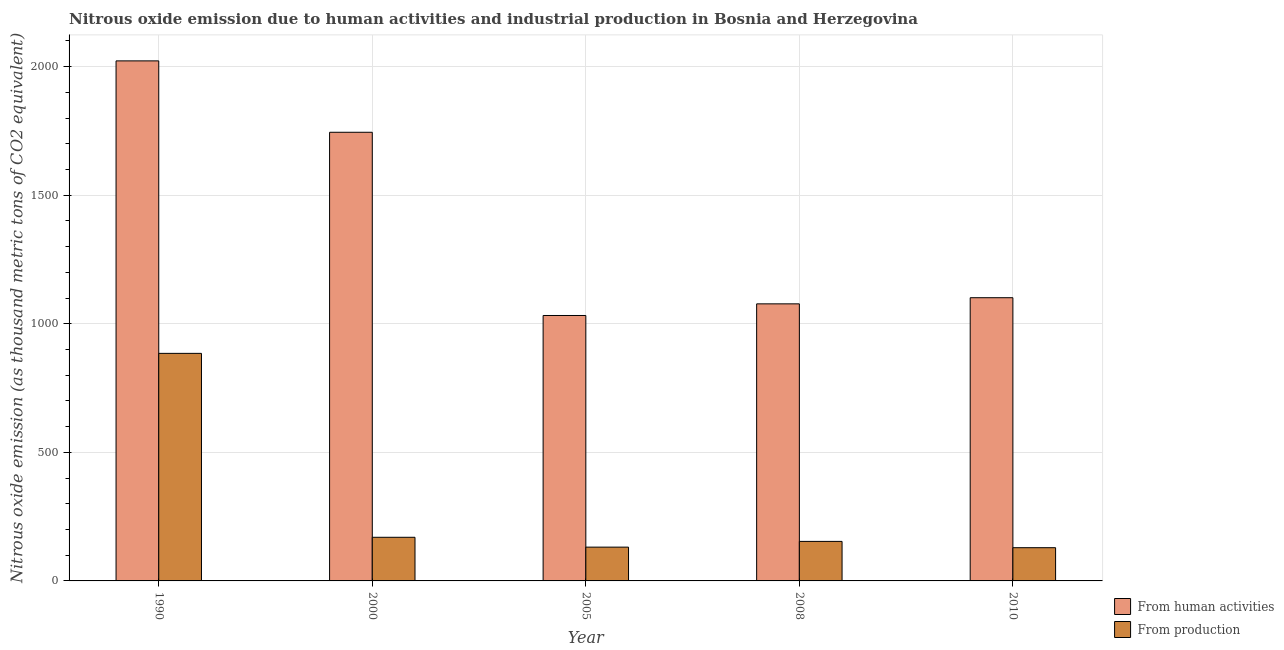How many groups of bars are there?
Ensure brevity in your answer.  5. How many bars are there on the 4th tick from the left?
Provide a succinct answer. 2. How many bars are there on the 3rd tick from the right?
Your answer should be compact. 2. In how many cases, is the number of bars for a given year not equal to the number of legend labels?
Offer a very short reply. 0. What is the amount of emissions from human activities in 2000?
Your answer should be very brief. 1744.9. Across all years, what is the maximum amount of emissions generated from industries?
Give a very brief answer. 885. Across all years, what is the minimum amount of emissions from human activities?
Offer a terse response. 1032.3. What is the total amount of emissions from human activities in the graph?
Ensure brevity in your answer.  6978.9. What is the difference between the amount of emissions from human activities in 1990 and that in 2010?
Your response must be concise. 921.1. What is the difference between the amount of emissions from human activities in 1990 and the amount of emissions generated from industries in 2010?
Keep it short and to the point. 921.1. What is the average amount of emissions generated from industries per year?
Give a very brief answer. 293.8. What is the ratio of the amount of emissions generated from industries in 2000 to that in 2008?
Offer a very short reply. 1.1. Is the amount of emissions from human activities in 2000 less than that in 2008?
Provide a succinct answer. No. Is the difference between the amount of emissions generated from industries in 2000 and 2008 greater than the difference between the amount of emissions from human activities in 2000 and 2008?
Your answer should be very brief. No. What is the difference between the highest and the second highest amount of emissions from human activities?
Keep it short and to the point. 277.7. What is the difference between the highest and the lowest amount of emissions generated from industries?
Provide a short and direct response. 755.8. In how many years, is the amount of emissions generated from industries greater than the average amount of emissions generated from industries taken over all years?
Keep it short and to the point. 1. What does the 2nd bar from the left in 2008 represents?
Make the answer very short. From production. What does the 1st bar from the right in 2010 represents?
Your answer should be compact. From production. How many bars are there?
Offer a terse response. 10. What is the difference between two consecutive major ticks on the Y-axis?
Your answer should be very brief. 500. Are the values on the major ticks of Y-axis written in scientific E-notation?
Provide a succinct answer. No. Does the graph contain grids?
Offer a very short reply. Yes. How many legend labels are there?
Give a very brief answer. 2. What is the title of the graph?
Make the answer very short. Nitrous oxide emission due to human activities and industrial production in Bosnia and Herzegovina. Does "Underweight" appear as one of the legend labels in the graph?
Provide a succinct answer. No. What is the label or title of the Y-axis?
Offer a terse response. Nitrous oxide emission (as thousand metric tons of CO2 equivalent). What is the Nitrous oxide emission (as thousand metric tons of CO2 equivalent) in From human activities in 1990?
Ensure brevity in your answer.  2022.6. What is the Nitrous oxide emission (as thousand metric tons of CO2 equivalent) of From production in 1990?
Keep it short and to the point. 885. What is the Nitrous oxide emission (as thousand metric tons of CO2 equivalent) in From human activities in 2000?
Offer a terse response. 1744.9. What is the Nitrous oxide emission (as thousand metric tons of CO2 equivalent) in From production in 2000?
Make the answer very short. 169.7. What is the Nitrous oxide emission (as thousand metric tons of CO2 equivalent) in From human activities in 2005?
Provide a succinct answer. 1032.3. What is the Nitrous oxide emission (as thousand metric tons of CO2 equivalent) in From production in 2005?
Ensure brevity in your answer.  131.4. What is the Nitrous oxide emission (as thousand metric tons of CO2 equivalent) of From human activities in 2008?
Offer a terse response. 1077.6. What is the Nitrous oxide emission (as thousand metric tons of CO2 equivalent) in From production in 2008?
Your answer should be compact. 153.7. What is the Nitrous oxide emission (as thousand metric tons of CO2 equivalent) of From human activities in 2010?
Offer a very short reply. 1101.5. What is the Nitrous oxide emission (as thousand metric tons of CO2 equivalent) of From production in 2010?
Ensure brevity in your answer.  129.2. Across all years, what is the maximum Nitrous oxide emission (as thousand metric tons of CO2 equivalent) of From human activities?
Offer a terse response. 2022.6. Across all years, what is the maximum Nitrous oxide emission (as thousand metric tons of CO2 equivalent) in From production?
Offer a terse response. 885. Across all years, what is the minimum Nitrous oxide emission (as thousand metric tons of CO2 equivalent) in From human activities?
Your response must be concise. 1032.3. Across all years, what is the minimum Nitrous oxide emission (as thousand metric tons of CO2 equivalent) in From production?
Your response must be concise. 129.2. What is the total Nitrous oxide emission (as thousand metric tons of CO2 equivalent) of From human activities in the graph?
Offer a terse response. 6978.9. What is the total Nitrous oxide emission (as thousand metric tons of CO2 equivalent) in From production in the graph?
Keep it short and to the point. 1469. What is the difference between the Nitrous oxide emission (as thousand metric tons of CO2 equivalent) in From human activities in 1990 and that in 2000?
Provide a succinct answer. 277.7. What is the difference between the Nitrous oxide emission (as thousand metric tons of CO2 equivalent) in From production in 1990 and that in 2000?
Offer a very short reply. 715.3. What is the difference between the Nitrous oxide emission (as thousand metric tons of CO2 equivalent) of From human activities in 1990 and that in 2005?
Provide a short and direct response. 990.3. What is the difference between the Nitrous oxide emission (as thousand metric tons of CO2 equivalent) of From production in 1990 and that in 2005?
Your response must be concise. 753.6. What is the difference between the Nitrous oxide emission (as thousand metric tons of CO2 equivalent) in From human activities in 1990 and that in 2008?
Your response must be concise. 945. What is the difference between the Nitrous oxide emission (as thousand metric tons of CO2 equivalent) of From production in 1990 and that in 2008?
Your answer should be compact. 731.3. What is the difference between the Nitrous oxide emission (as thousand metric tons of CO2 equivalent) in From human activities in 1990 and that in 2010?
Give a very brief answer. 921.1. What is the difference between the Nitrous oxide emission (as thousand metric tons of CO2 equivalent) in From production in 1990 and that in 2010?
Your answer should be very brief. 755.8. What is the difference between the Nitrous oxide emission (as thousand metric tons of CO2 equivalent) in From human activities in 2000 and that in 2005?
Your answer should be very brief. 712.6. What is the difference between the Nitrous oxide emission (as thousand metric tons of CO2 equivalent) in From production in 2000 and that in 2005?
Your answer should be very brief. 38.3. What is the difference between the Nitrous oxide emission (as thousand metric tons of CO2 equivalent) in From human activities in 2000 and that in 2008?
Provide a succinct answer. 667.3. What is the difference between the Nitrous oxide emission (as thousand metric tons of CO2 equivalent) in From human activities in 2000 and that in 2010?
Give a very brief answer. 643.4. What is the difference between the Nitrous oxide emission (as thousand metric tons of CO2 equivalent) of From production in 2000 and that in 2010?
Offer a very short reply. 40.5. What is the difference between the Nitrous oxide emission (as thousand metric tons of CO2 equivalent) of From human activities in 2005 and that in 2008?
Offer a very short reply. -45.3. What is the difference between the Nitrous oxide emission (as thousand metric tons of CO2 equivalent) of From production in 2005 and that in 2008?
Ensure brevity in your answer.  -22.3. What is the difference between the Nitrous oxide emission (as thousand metric tons of CO2 equivalent) of From human activities in 2005 and that in 2010?
Your answer should be very brief. -69.2. What is the difference between the Nitrous oxide emission (as thousand metric tons of CO2 equivalent) in From production in 2005 and that in 2010?
Offer a terse response. 2.2. What is the difference between the Nitrous oxide emission (as thousand metric tons of CO2 equivalent) of From human activities in 2008 and that in 2010?
Make the answer very short. -23.9. What is the difference between the Nitrous oxide emission (as thousand metric tons of CO2 equivalent) in From human activities in 1990 and the Nitrous oxide emission (as thousand metric tons of CO2 equivalent) in From production in 2000?
Ensure brevity in your answer.  1852.9. What is the difference between the Nitrous oxide emission (as thousand metric tons of CO2 equivalent) of From human activities in 1990 and the Nitrous oxide emission (as thousand metric tons of CO2 equivalent) of From production in 2005?
Your answer should be very brief. 1891.2. What is the difference between the Nitrous oxide emission (as thousand metric tons of CO2 equivalent) of From human activities in 1990 and the Nitrous oxide emission (as thousand metric tons of CO2 equivalent) of From production in 2008?
Provide a succinct answer. 1868.9. What is the difference between the Nitrous oxide emission (as thousand metric tons of CO2 equivalent) in From human activities in 1990 and the Nitrous oxide emission (as thousand metric tons of CO2 equivalent) in From production in 2010?
Give a very brief answer. 1893.4. What is the difference between the Nitrous oxide emission (as thousand metric tons of CO2 equivalent) of From human activities in 2000 and the Nitrous oxide emission (as thousand metric tons of CO2 equivalent) of From production in 2005?
Your answer should be compact. 1613.5. What is the difference between the Nitrous oxide emission (as thousand metric tons of CO2 equivalent) of From human activities in 2000 and the Nitrous oxide emission (as thousand metric tons of CO2 equivalent) of From production in 2008?
Offer a terse response. 1591.2. What is the difference between the Nitrous oxide emission (as thousand metric tons of CO2 equivalent) in From human activities in 2000 and the Nitrous oxide emission (as thousand metric tons of CO2 equivalent) in From production in 2010?
Ensure brevity in your answer.  1615.7. What is the difference between the Nitrous oxide emission (as thousand metric tons of CO2 equivalent) in From human activities in 2005 and the Nitrous oxide emission (as thousand metric tons of CO2 equivalent) in From production in 2008?
Keep it short and to the point. 878.6. What is the difference between the Nitrous oxide emission (as thousand metric tons of CO2 equivalent) in From human activities in 2005 and the Nitrous oxide emission (as thousand metric tons of CO2 equivalent) in From production in 2010?
Offer a terse response. 903.1. What is the difference between the Nitrous oxide emission (as thousand metric tons of CO2 equivalent) in From human activities in 2008 and the Nitrous oxide emission (as thousand metric tons of CO2 equivalent) in From production in 2010?
Provide a succinct answer. 948.4. What is the average Nitrous oxide emission (as thousand metric tons of CO2 equivalent) of From human activities per year?
Your answer should be very brief. 1395.78. What is the average Nitrous oxide emission (as thousand metric tons of CO2 equivalent) of From production per year?
Your answer should be very brief. 293.8. In the year 1990, what is the difference between the Nitrous oxide emission (as thousand metric tons of CO2 equivalent) of From human activities and Nitrous oxide emission (as thousand metric tons of CO2 equivalent) of From production?
Your answer should be very brief. 1137.6. In the year 2000, what is the difference between the Nitrous oxide emission (as thousand metric tons of CO2 equivalent) in From human activities and Nitrous oxide emission (as thousand metric tons of CO2 equivalent) in From production?
Your answer should be very brief. 1575.2. In the year 2005, what is the difference between the Nitrous oxide emission (as thousand metric tons of CO2 equivalent) in From human activities and Nitrous oxide emission (as thousand metric tons of CO2 equivalent) in From production?
Provide a succinct answer. 900.9. In the year 2008, what is the difference between the Nitrous oxide emission (as thousand metric tons of CO2 equivalent) in From human activities and Nitrous oxide emission (as thousand metric tons of CO2 equivalent) in From production?
Ensure brevity in your answer.  923.9. In the year 2010, what is the difference between the Nitrous oxide emission (as thousand metric tons of CO2 equivalent) of From human activities and Nitrous oxide emission (as thousand metric tons of CO2 equivalent) of From production?
Make the answer very short. 972.3. What is the ratio of the Nitrous oxide emission (as thousand metric tons of CO2 equivalent) of From human activities in 1990 to that in 2000?
Your answer should be compact. 1.16. What is the ratio of the Nitrous oxide emission (as thousand metric tons of CO2 equivalent) of From production in 1990 to that in 2000?
Provide a succinct answer. 5.22. What is the ratio of the Nitrous oxide emission (as thousand metric tons of CO2 equivalent) in From human activities in 1990 to that in 2005?
Ensure brevity in your answer.  1.96. What is the ratio of the Nitrous oxide emission (as thousand metric tons of CO2 equivalent) of From production in 1990 to that in 2005?
Provide a short and direct response. 6.74. What is the ratio of the Nitrous oxide emission (as thousand metric tons of CO2 equivalent) in From human activities in 1990 to that in 2008?
Give a very brief answer. 1.88. What is the ratio of the Nitrous oxide emission (as thousand metric tons of CO2 equivalent) of From production in 1990 to that in 2008?
Give a very brief answer. 5.76. What is the ratio of the Nitrous oxide emission (as thousand metric tons of CO2 equivalent) of From human activities in 1990 to that in 2010?
Your answer should be compact. 1.84. What is the ratio of the Nitrous oxide emission (as thousand metric tons of CO2 equivalent) in From production in 1990 to that in 2010?
Provide a short and direct response. 6.85. What is the ratio of the Nitrous oxide emission (as thousand metric tons of CO2 equivalent) of From human activities in 2000 to that in 2005?
Provide a short and direct response. 1.69. What is the ratio of the Nitrous oxide emission (as thousand metric tons of CO2 equivalent) of From production in 2000 to that in 2005?
Provide a succinct answer. 1.29. What is the ratio of the Nitrous oxide emission (as thousand metric tons of CO2 equivalent) in From human activities in 2000 to that in 2008?
Make the answer very short. 1.62. What is the ratio of the Nitrous oxide emission (as thousand metric tons of CO2 equivalent) of From production in 2000 to that in 2008?
Make the answer very short. 1.1. What is the ratio of the Nitrous oxide emission (as thousand metric tons of CO2 equivalent) of From human activities in 2000 to that in 2010?
Give a very brief answer. 1.58. What is the ratio of the Nitrous oxide emission (as thousand metric tons of CO2 equivalent) in From production in 2000 to that in 2010?
Provide a short and direct response. 1.31. What is the ratio of the Nitrous oxide emission (as thousand metric tons of CO2 equivalent) of From human activities in 2005 to that in 2008?
Your answer should be very brief. 0.96. What is the ratio of the Nitrous oxide emission (as thousand metric tons of CO2 equivalent) of From production in 2005 to that in 2008?
Your answer should be very brief. 0.85. What is the ratio of the Nitrous oxide emission (as thousand metric tons of CO2 equivalent) in From human activities in 2005 to that in 2010?
Your answer should be compact. 0.94. What is the ratio of the Nitrous oxide emission (as thousand metric tons of CO2 equivalent) in From production in 2005 to that in 2010?
Your answer should be very brief. 1.02. What is the ratio of the Nitrous oxide emission (as thousand metric tons of CO2 equivalent) in From human activities in 2008 to that in 2010?
Make the answer very short. 0.98. What is the ratio of the Nitrous oxide emission (as thousand metric tons of CO2 equivalent) of From production in 2008 to that in 2010?
Give a very brief answer. 1.19. What is the difference between the highest and the second highest Nitrous oxide emission (as thousand metric tons of CO2 equivalent) of From human activities?
Your response must be concise. 277.7. What is the difference between the highest and the second highest Nitrous oxide emission (as thousand metric tons of CO2 equivalent) in From production?
Offer a very short reply. 715.3. What is the difference between the highest and the lowest Nitrous oxide emission (as thousand metric tons of CO2 equivalent) of From human activities?
Offer a very short reply. 990.3. What is the difference between the highest and the lowest Nitrous oxide emission (as thousand metric tons of CO2 equivalent) of From production?
Keep it short and to the point. 755.8. 